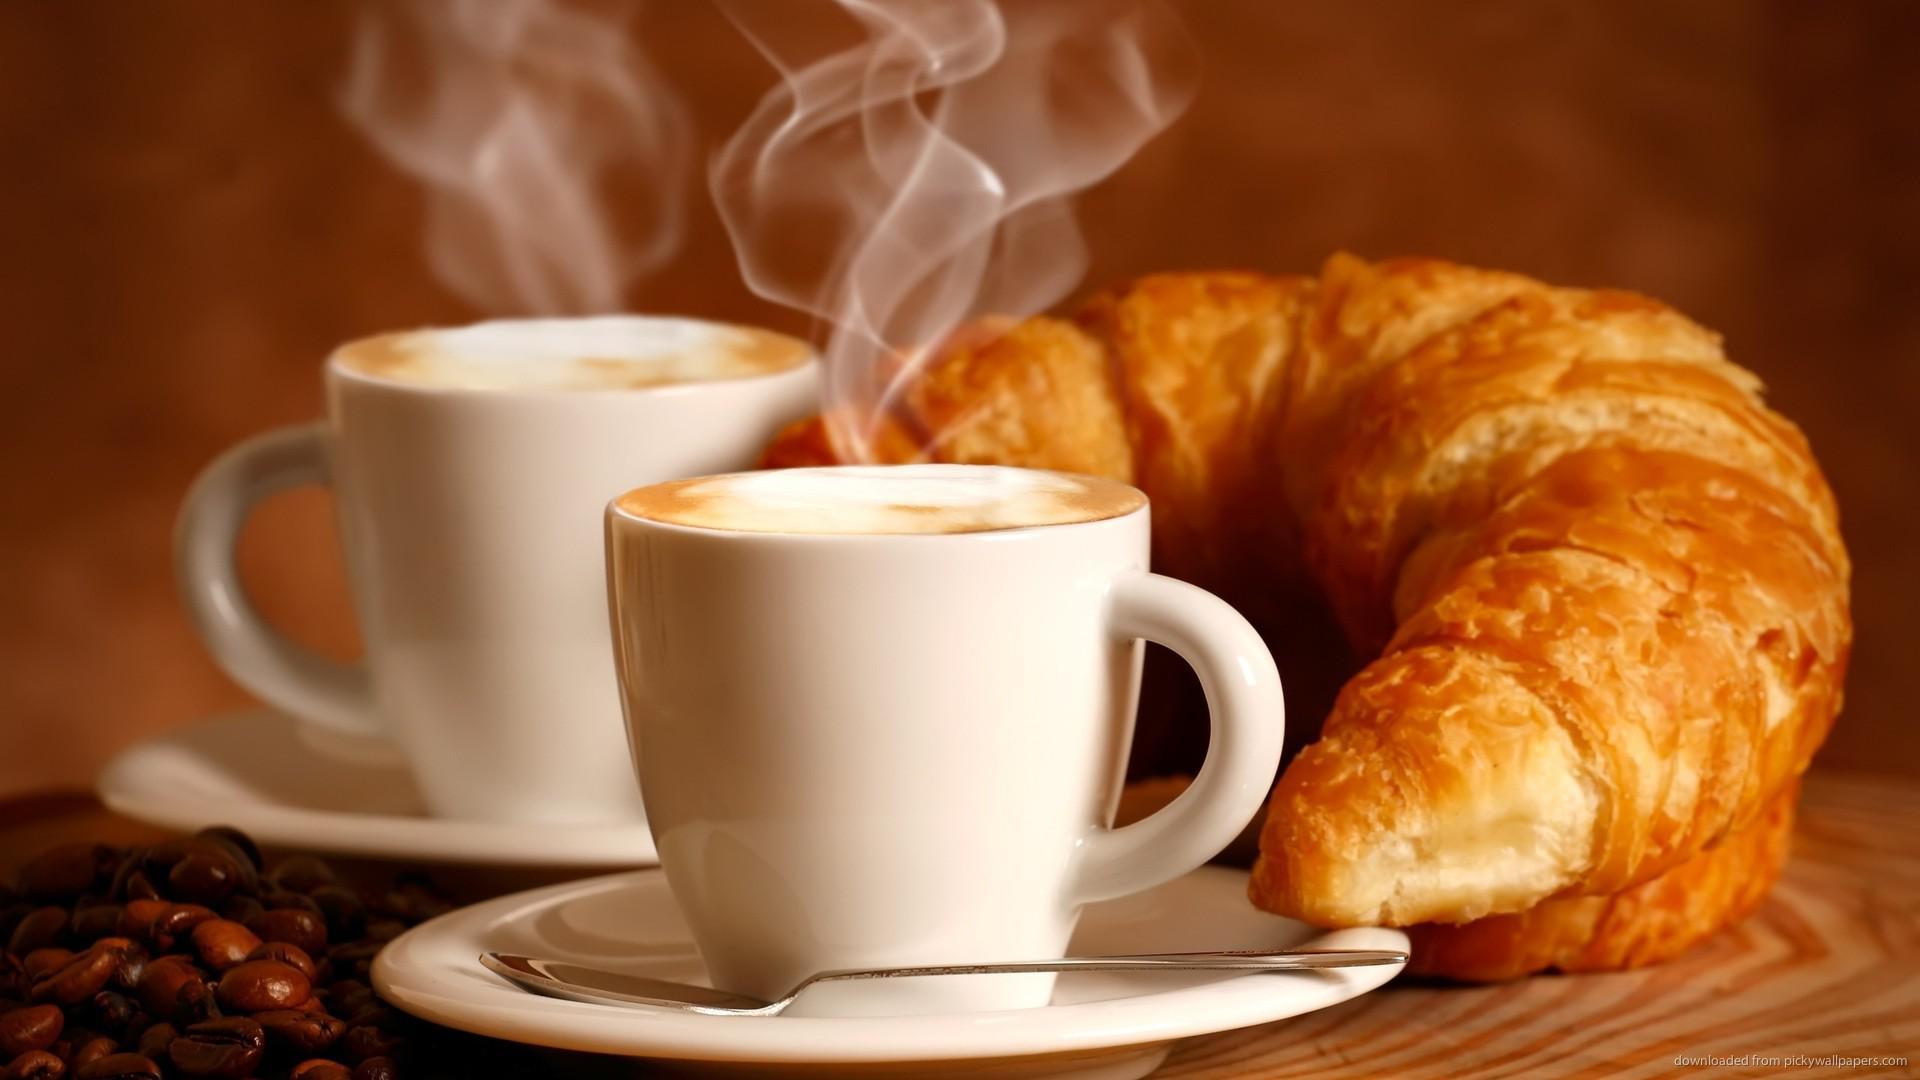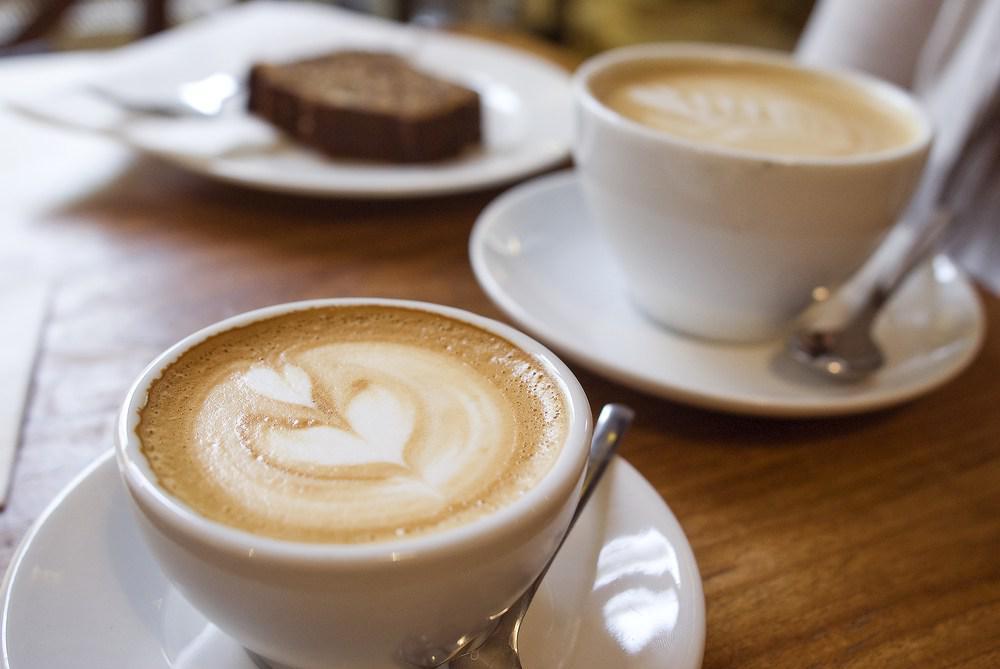The first image is the image on the left, the second image is the image on the right. Analyze the images presented: Is the assertion "At least one image shows a pair of filled cups with silver spoons nearby." valid? Answer yes or no. Yes. 